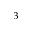<formula> <loc_0><loc_0><loc_500><loc_500>^ { 3 }</formula> 